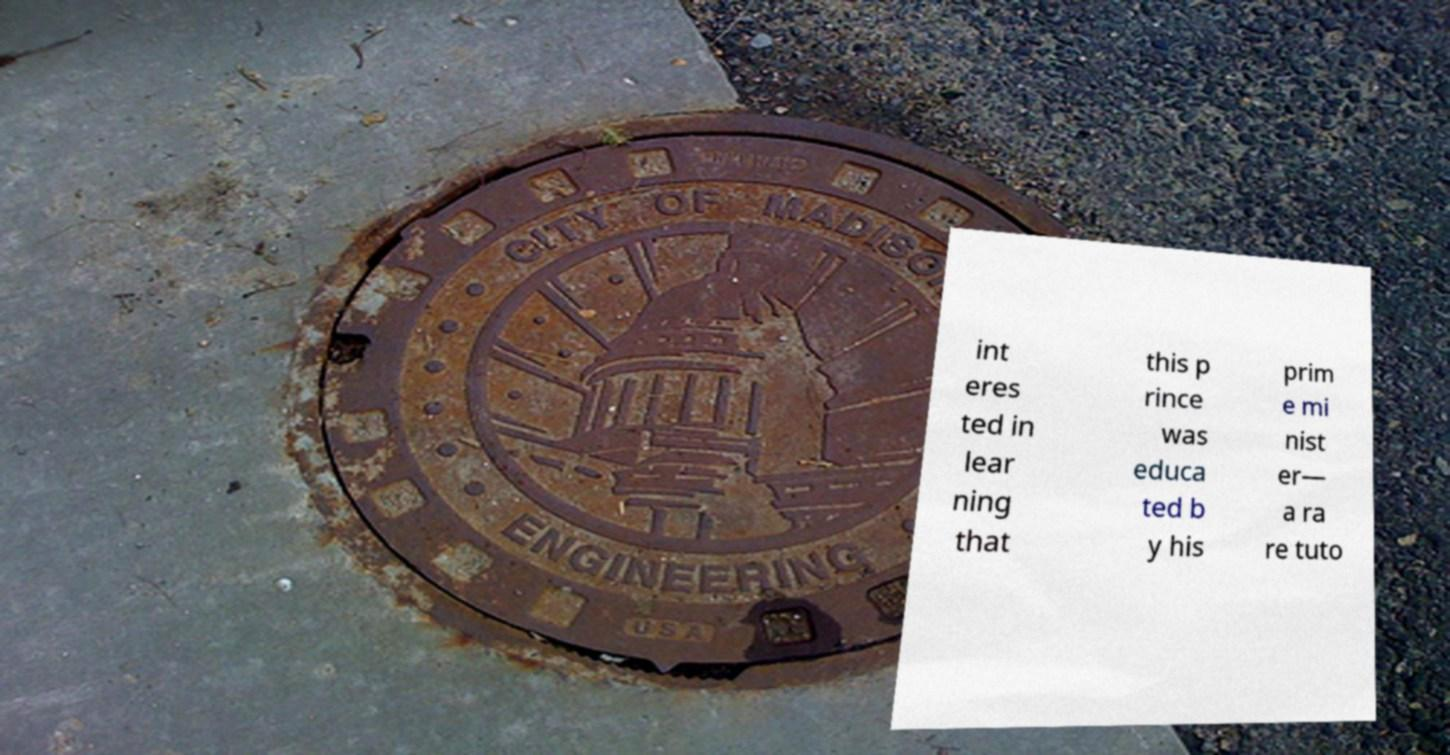Could you extract and type out the text from this image? int eres ted in lear ning that this p rince was educa ted b y his prim e mi nist er— a ra re tuto 